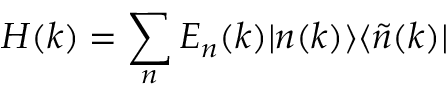<formula> <loc_0><loc_0><loc_500><loc_500>H ( k ) = \sum _ { n } E _ { n } ( k ) | n ( k ) \rangle \langle \widetilde { n } ( k ) |</formula> 